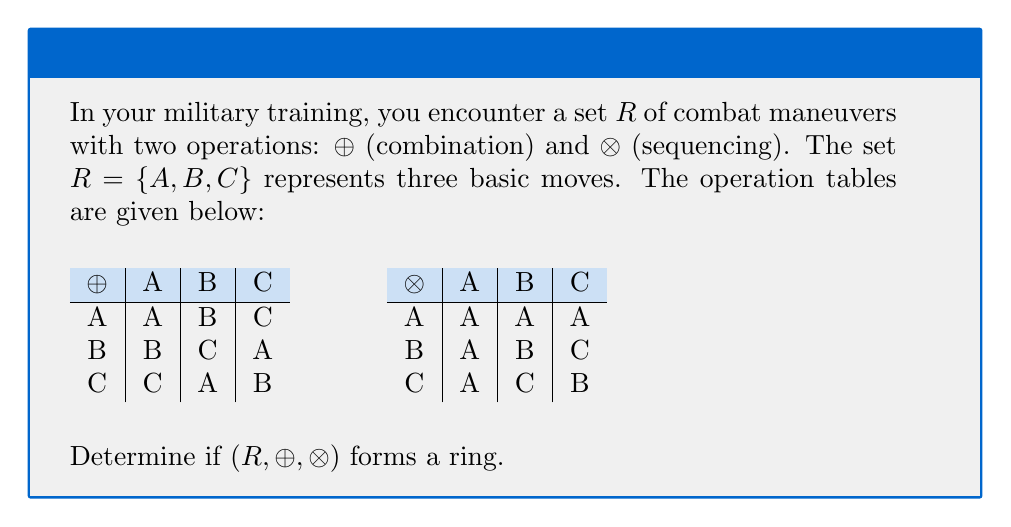Provide a solution to this math problem. To determine if $(R, ⊕, ⊗)$ forms a ring, we need to check if it satisfies all ring axioms:

1. $(R, ⊕)$ is an abelian group:
   a) Closure: Satisfied (all results are in $R$)
   b) Associativity: $(a ⊕ b) ⊕ c = a ⊕ (b ⊕ c)$ for all $a,b,c \in R$ (can be verified)
   c) Commutativity: $a ⊕ b = b ⊕ a$ for all $a,b \in R$ (satisfied by the table)
   d) Identity: $A$ is the identity element ($ A ⊕ x = x ⊕ A = x$ for all $x \in R$)
   e) Inverse: Each element is its own inverse under ⊕

2. $(R, ⊗)$ is a monoid:
   a) Closure: Satisfied (all results are in $R$)
   b) Associativity: $(a ⊗ b) ⊗ c = a ⊗ (b ⊗ c)$ for all $a,b,c \in R$ (can be verified)
   c) Identity: $B$ is the identity element ($ B ⊗ x = x ⊗ B = x$ for all $x \in R$)

3. Distributivity:
   a) Left: $a ⊗ (b ⊕ c) = (a ⊗ b) ⊕ (a ⊗ c)$ for all $a,b,c \in R$
   b) Right: $(a ⊕ b) ⊗ c = (a ⊗ c) ⊕ (b ⊗ c)$ for all $a,b,c \in R$

Let's check left distributivity for $A ⊗ (B ⊕ C)$:
$A ⊗ (B ⊕ C) = A ⊗ A = A$
$(A ⊗ B) ⊕ (A ⊗ C) = A ⊕ A = A$

This property holds. Similar checks can be done for all combinations.

All ring axioms are satisfied, so $(R, ⊕, ⊗)$ forms a ring.
Answer: Yes, $(R, ⊕, ⊗)$ forms a ring. 